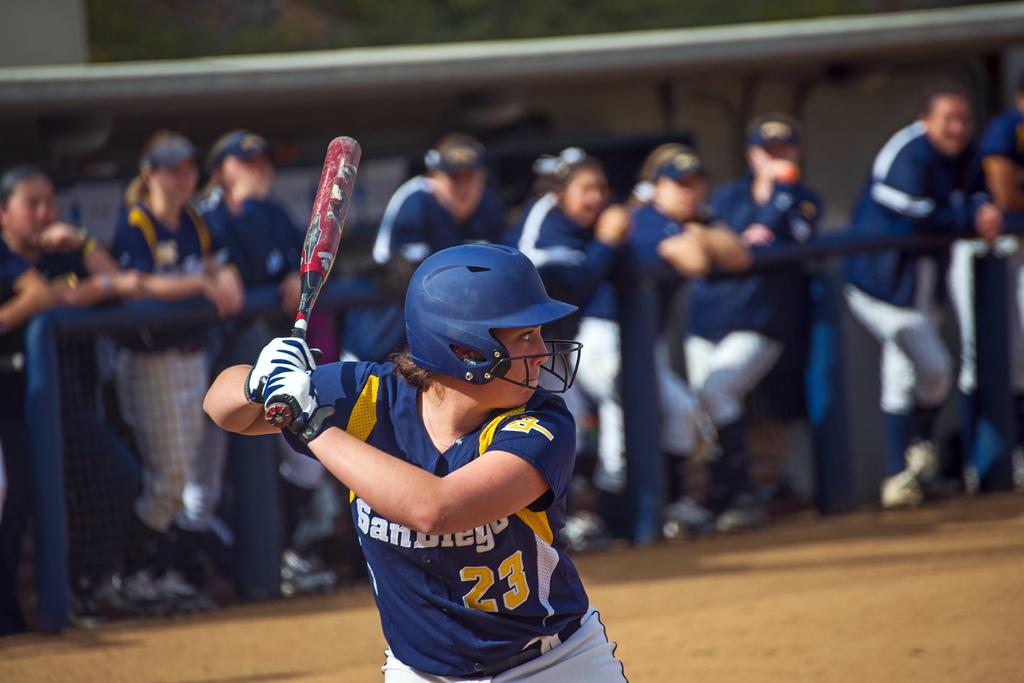What is the number on the batters jersey?
Make the answer very short. 23. 